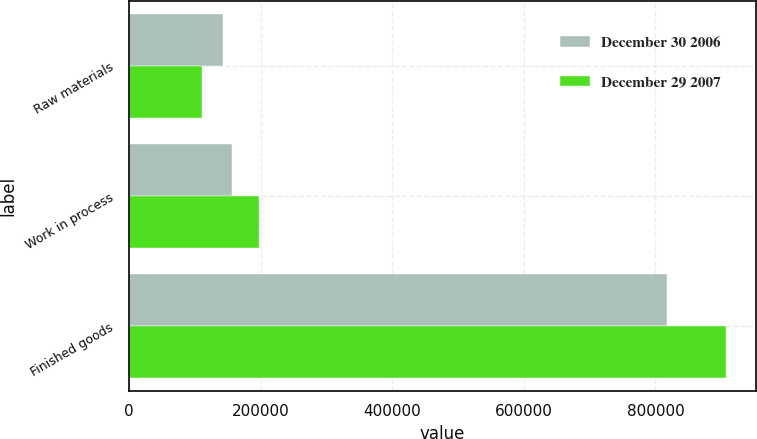<chart> <loc_0><loc_0><loc_500><loc_500><stacked_bar_chart><ecel><fcel>Raw materials<fcel>Work in process<fcel>Finished goods<nl><fcel>December 30 2006<fcel>143430<fcel>156052<fcel>817570<nl><fcel>December 29 2007<fcel>111503<fcel>197645<fcel>907353<nl></chart> 